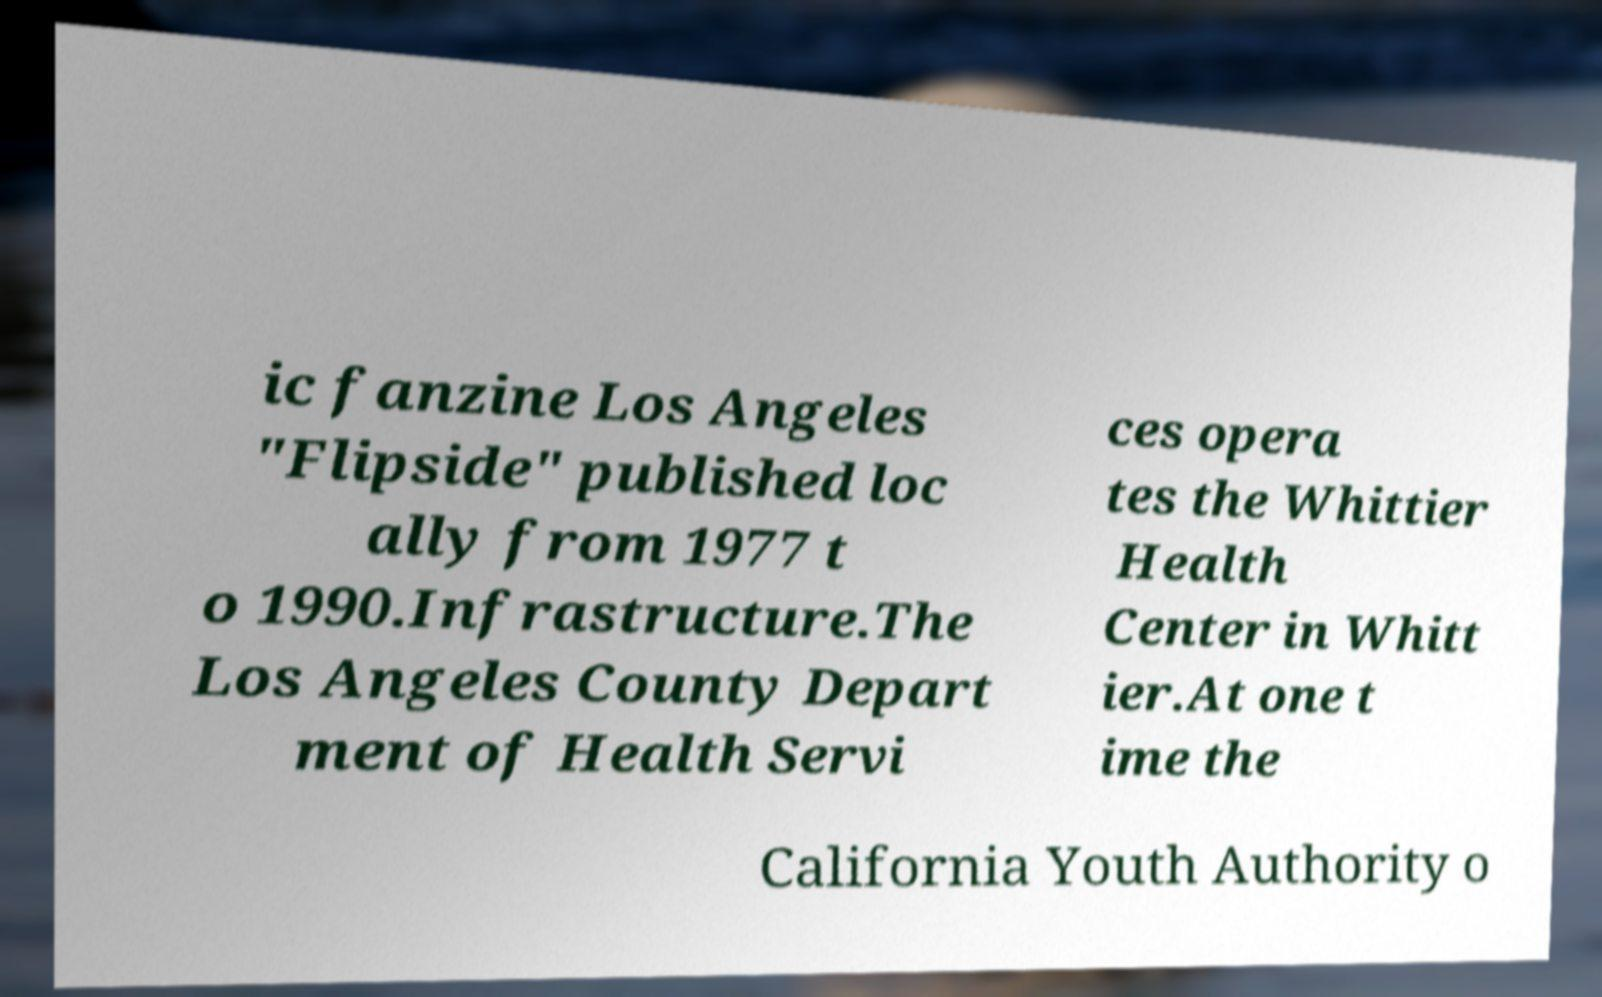Please identify and transcribe the text found in this image. ic fanzine Los Angeles "Flipside" published loc ally from 1977 t o 1990.Infrastructure.The Los Angeles County Depart ment of Health Servi ces opera tes the Whittier Health Center in Whitt ier.At one t ime the California Youth Authority o 